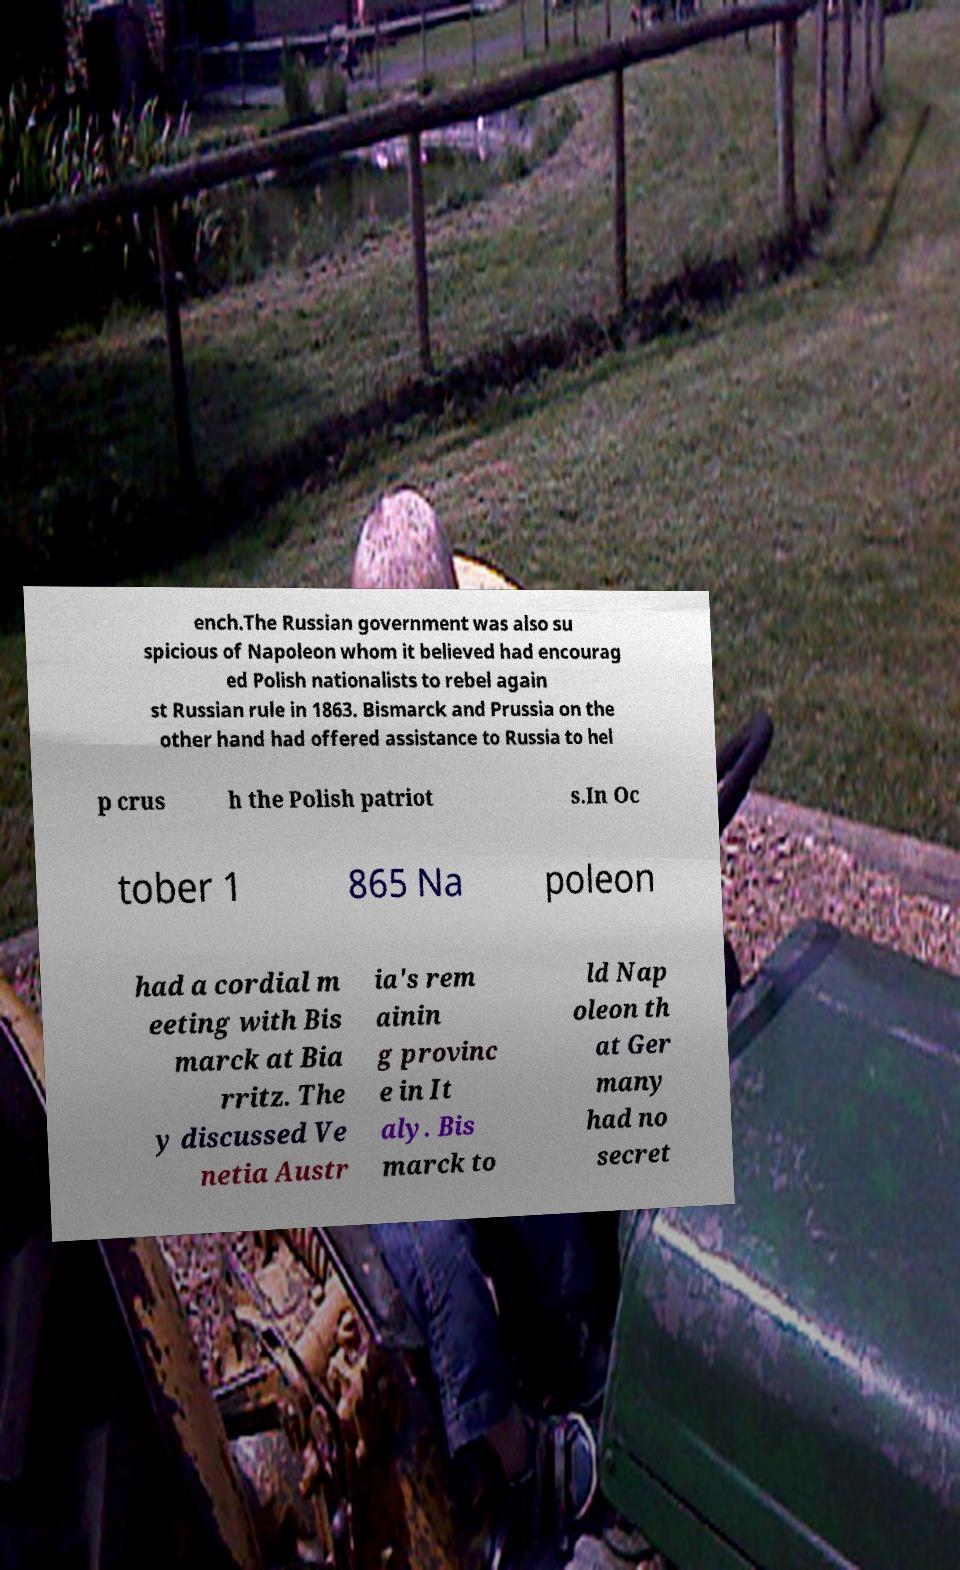I need the written content from this picture converted into text. Can you do that? ench.The Russian government was also su spicious of Napoleon whom it believed had encourag ed Polish nationalists to rebel again st Russian rule in 1863. Bismarck and Prussia on the other hand had offered assistance to Russia to hel p crus h the Polish patriot s.In Oc tober 1 865 Na poleon had a cordial m eeting with Bis marck at Bia rritz. The y discussed Ve netia Austr ia's rem ainin g provinc e in It aly. Bis marck to ld Nap oleon th at Ger many had no secret 